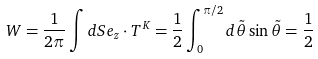<formula> <loc_0><loc_0><loc_500><loc_500>W = \frac { 1 } { 2 \pi } \int d S { e } _ { z } \cdot { T } ^ { K } = \frac { 1 } { 2 } \int ^ { \pi / 2 } _ { 0 } d \tilde { \theta } \sin \tilde { \theta } = \frac { 1 } { 2 }</formula> 